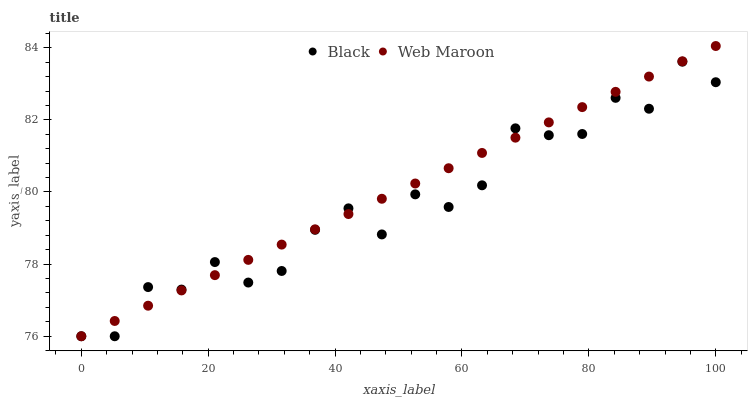Does Black have the minimum area under the curve?
Answer yes or no. Yes. Does Web Maroon have the maximum area under the curve?
Answer yes or no. Yes. Does Black have the maximum area under the curve?
Answer yes or no. No. Is Web Maroon the smoothest?
Answer yes or no. Yes. Is Black the roughest?
Answer yes or no. Yes. Is Black the smoothest?
Answer yes or no. No. Does Web Maroon have the lowest value?
Answer yes or no. Yes. Does Web Maroon have the highest value?
Answer yes or no. Yes. Does Black have the highest value?
Answer yes or no. No. Does Black intersect Web Maroon?
Answer yes or no. Yes. Is Black less than Web Maroon?
Answer yes or no. No. Is Black greater than Web Maroon?
Answer yes or no. No. 